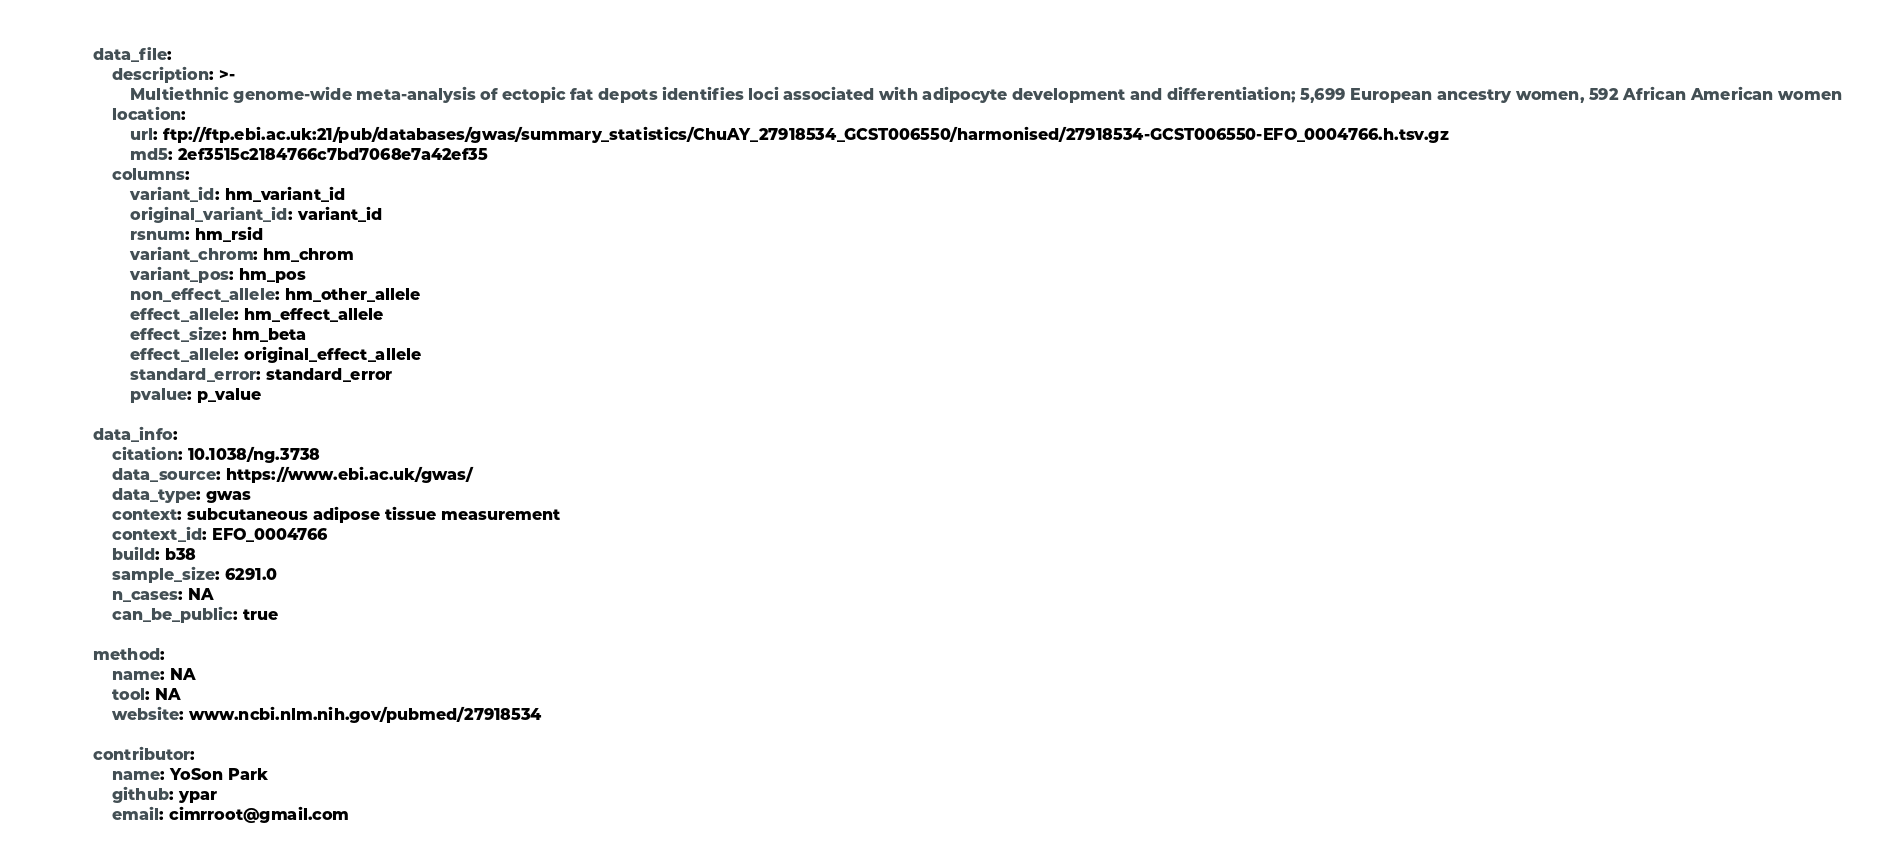Convert code to text. <code><loc_0><loc_0><loc_500><loc_500><_YAML_>
data_file:
    description: >-
        Multiethnic genome-wide meta-analysis of ectopic fat depots identifies loci associated with adipocyte development and differentiation; 5,699 European ancestry women, 592 African American women
    location:
        url: ftp://ftp.ebi.ac.uk:21/pub/databases/gwas/summary_statistics/ChuAY_27918534_GCST006550/harmonised/27918534-GCST006550-EFO_0004766.h.tsv.gz
        md5: 2ef3515c2184766c7bd7068e7a42ef35
    columns:
        variant_id: hm_variant_id
        original_variant_id: variant_id
        rsnum: hm_rsid
        variant_chrom: hm_chrom
        variant_pos: hm_pos
        non_effect_allele: hm_other_allele
        effect_allele: hm_effect_allele
        effect_size: hm_beta
        effect_allele: original_effect_allele
        standard_error: standard_error
        pvalue: p_value

data_info:
    citation: 10.1038/ng.3738
    data_source: https://www.ebi.ac.uk/gwas/
    data_type: gwas
    context: subcutaneous adipose tissue measurement
    context_id: EFO_0004766
    build: b38
    sample_size: 6291.0
    n_cases: NA
    can_be_public: true

method:
    name: NA
    tool: NA
    website: www.ncbi.nlm.nih.gov/pubmed/27918534

contributor:
    name: YoSon Park
    github: ypar
    email: cimrroot@gmail.com

</code> 